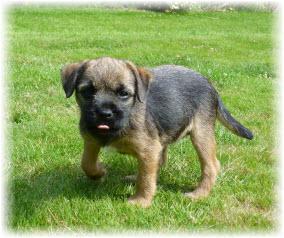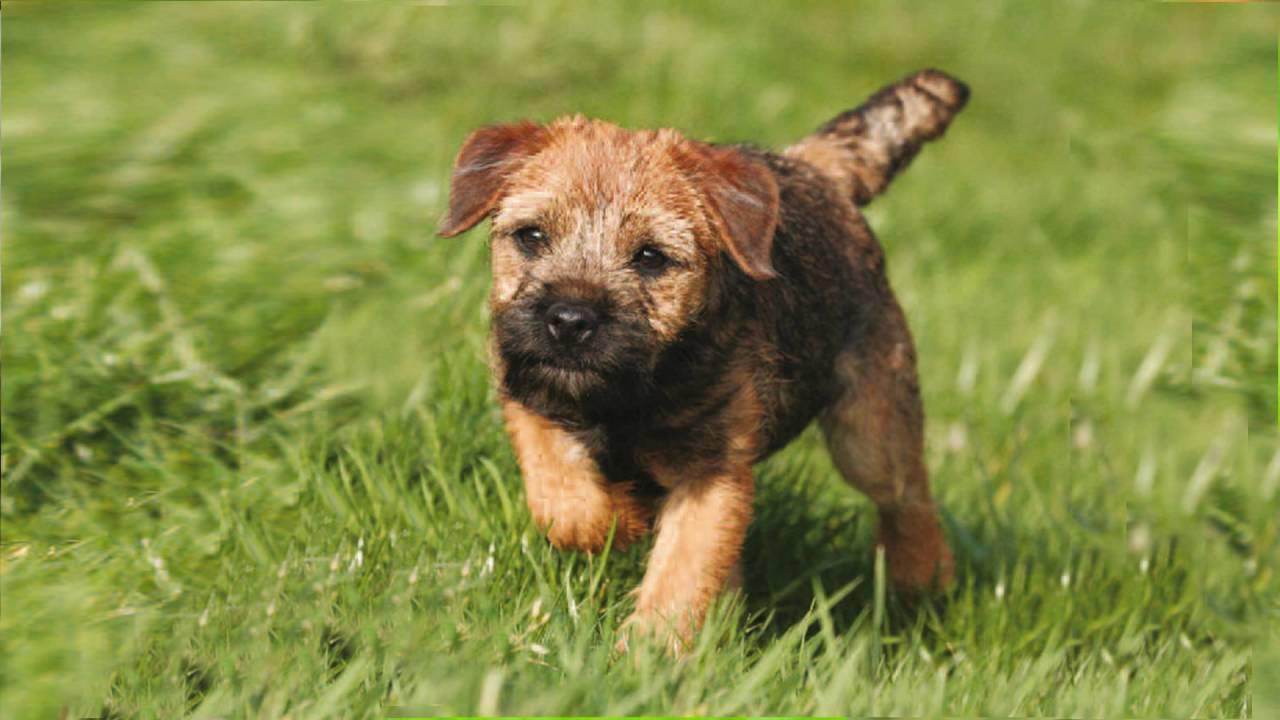The first image is the image on the left, the second image is the image on the right. For the images displayed, is the sentence "Left image shows one dog wearing something colorful around its neck." factually correct? Answer yes or no. No. The first image is the image on the left, the second image is the image on the right. Assess this claim about the two images: "One puppy is wearing a colorful color.". Correct or not? Answer yes or no. No. 